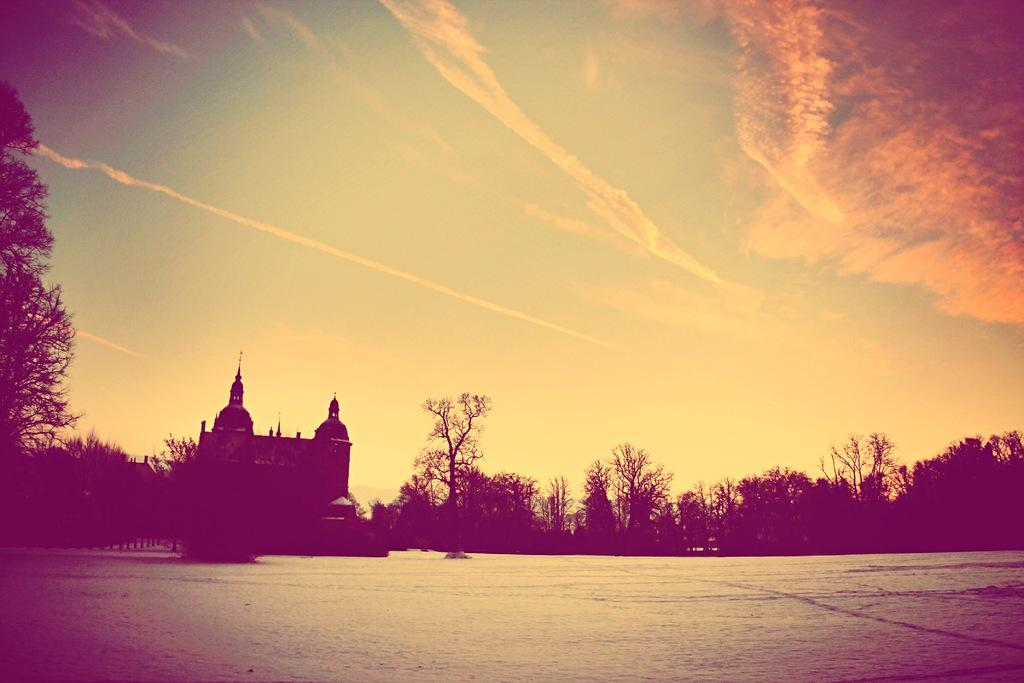What is at the bottom of the image? There is water at the bottom of the image. What can be seen in the background of the image? There is a building and trees in the background of the image. What is visible at the top of the image? The sky is visible at the top of the image. Has the image been altered in any way? Yes, the image has been edited. How does the passenger interact with the nerve in the image? There is no passenger or nerve present in the image. 